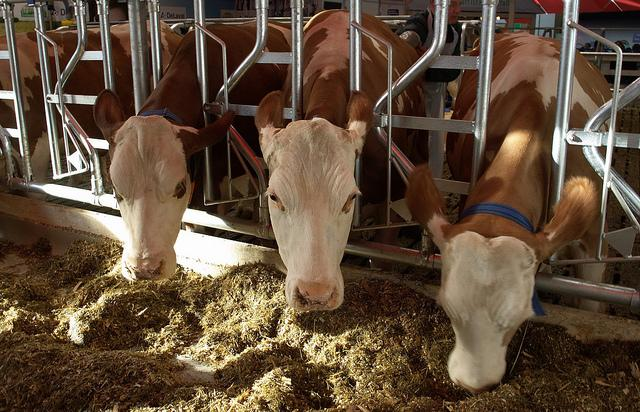Why are the animals putting their face to the ground? Please explain your reasoning. to eat. There is food on the ground. 